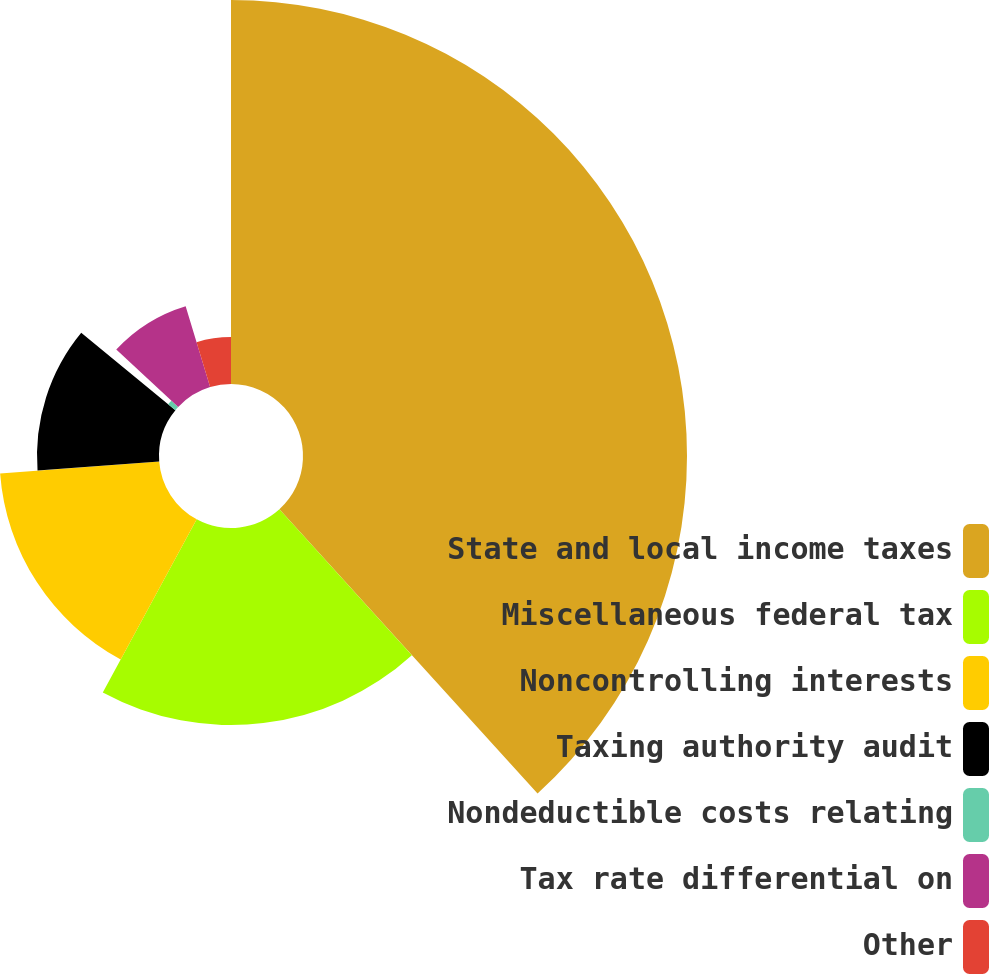Convert chart. <chart><loc_0><loc_0><loc_500><loc_500><pie_chart><fcel>State and local income taxes<fcel>Miscellaneous federal tax<fcel>Noncontrolling interests<fcel>Taxing authority audit<fcel>Nondeductible costs relating<fcel>Tax rate differential on<fcel>Other<nl><fcel>38.27%<fcel>19.64%<fcel>15.9%<fcel>12.16%<fcel>0.94%<fcel>8.42%<fcel>4.68%<nl></chart> 